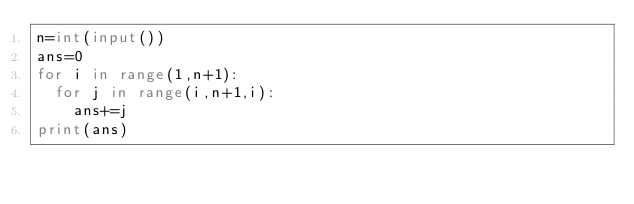Convert code to text. <code><loc_0><loc_0><loc_500><loc_500><_Python_>n=int(input())
ans=0
for i in range(1,n+1):
  for j in range(i,n+1,i):
    ans+=j
print(ans)
</code> 